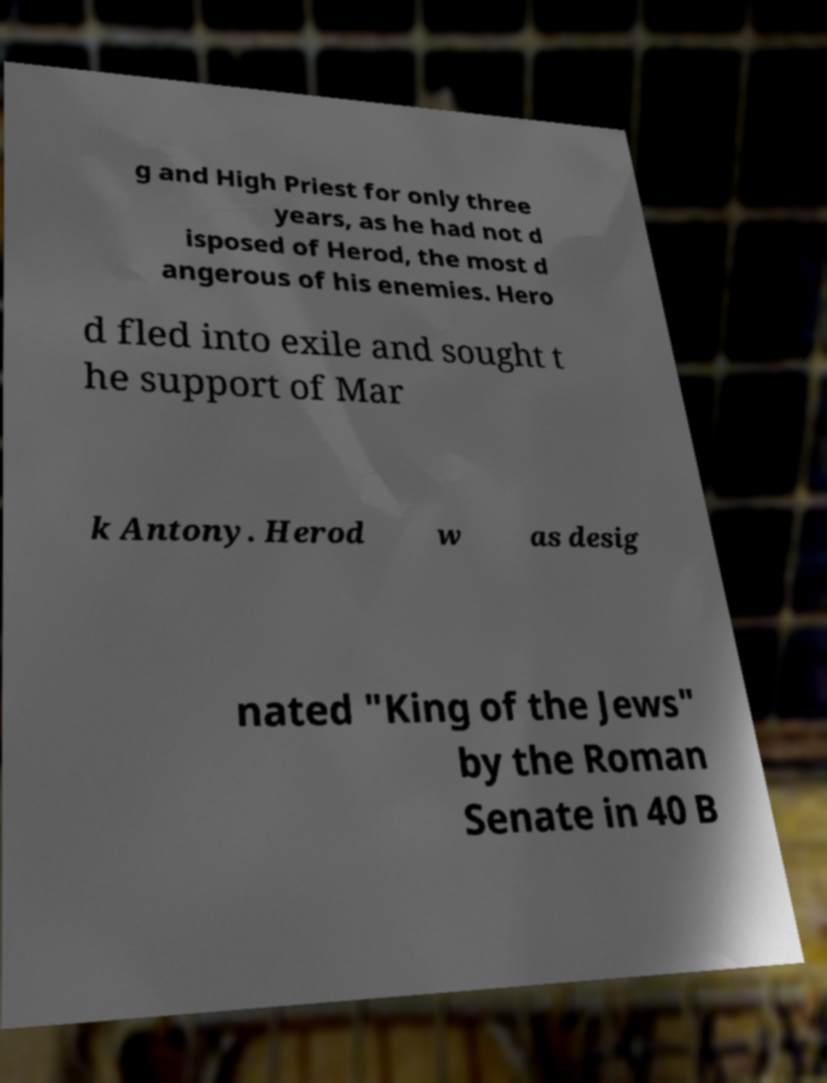Could you extract and type out the text from this image? g and High Priest for only three years, as he had not d isposed of Herod, the most d angerous of his enemies. Hero d fled into exile and sought t he support of Mar k Antony. Herod w as desig nated "King of the Jews" by the Roman Senate in 40 B 